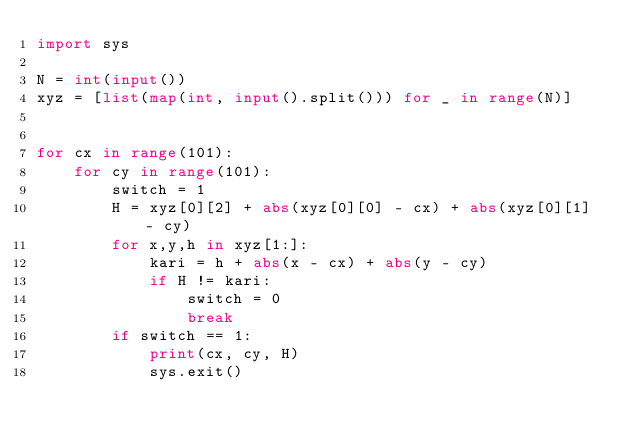Convert code to text. <code><loc_0><loc_0><loc_500><loc_500><_Python_>import sys

N = int(input())
xyz = [list(map(int, input().split())) for _ in range(N)]


for cx in range(101):
    for cy in range(101):
        switch = 1
        H = xyz[0][2] + abs(xyz[0][0] - cx) + abs(xyz[0][1] - cy)
        for x,y,h in xyz[1:]:
            kari = h + abs(x - cx) + abs(y - cy)
            if H != kari:
                switch = 0
                break
        if switch == 1:
            print(cx, cy, H)
            sys.exit()
            </code> 